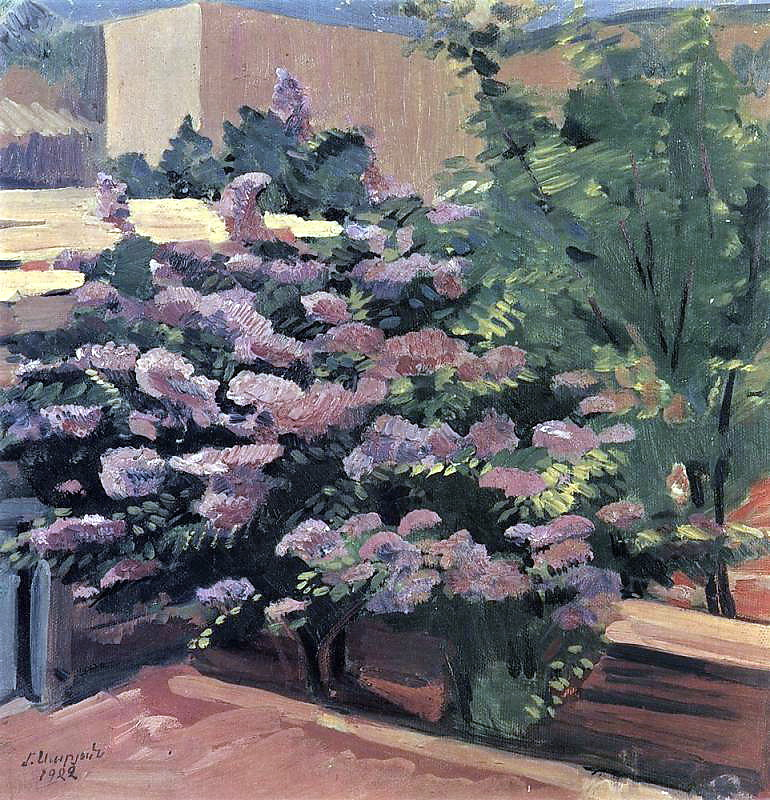What stories might be hidden in this garden? This garden, with its lush foliage and blooming flowers, could be the setting for countless hidden stories. Perhaps it is where a young poet comes to write and find inspiration in the vibrant colors and soothing sounds. It might also be a secret meeting spot for two lovers who cherish the privacy and beauty of the garden for their clandestine rendezvous. Another hidden story could revolve around an elderly gardener who has tended to this garden for decades, each flower planted with care and each shrub shaped with love, resulting in a sanctuary that holds decades of memories and personal history. These imagined narratives lend a sense of mystery and romance to the serene and picturesque setting. 